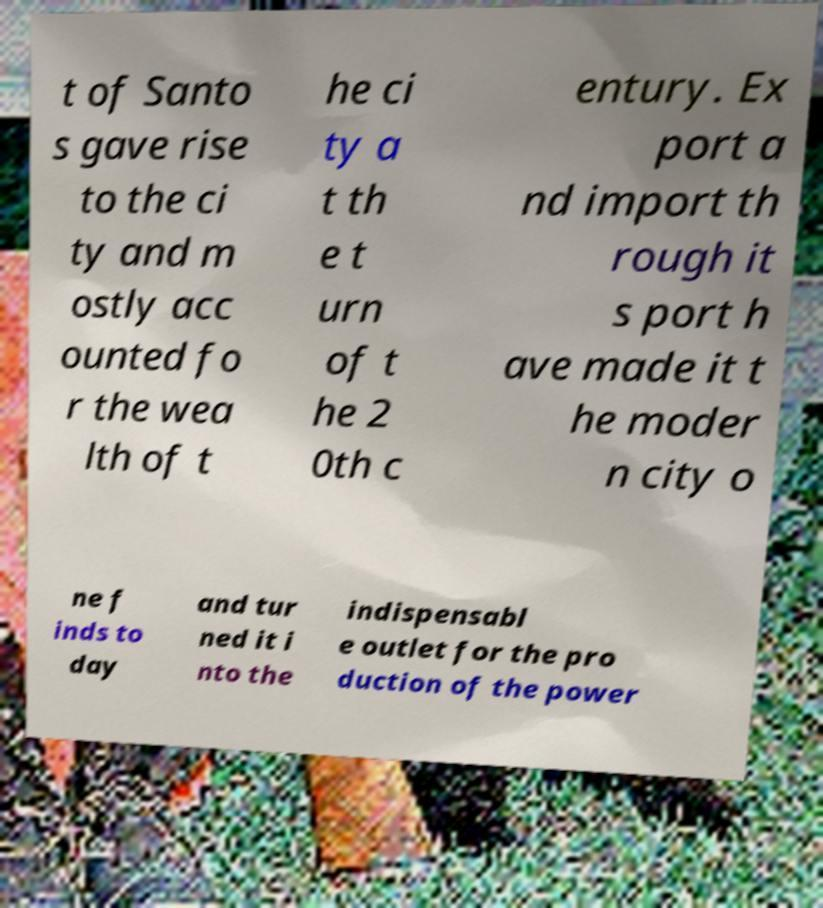Can you accurately transcribe the text from the provided image for me? t of Santo s gave rise to the ci ty and m ostly acc ounted fo r the wea lth of t he ci ty a t th e t urn of t he 2 0th c entury. Ex port a nd import th rough it s port h ave made it t he moder n city o ne f inds to day and tur ned it i nto the indispensabl e outlet for the pro duction of the power 